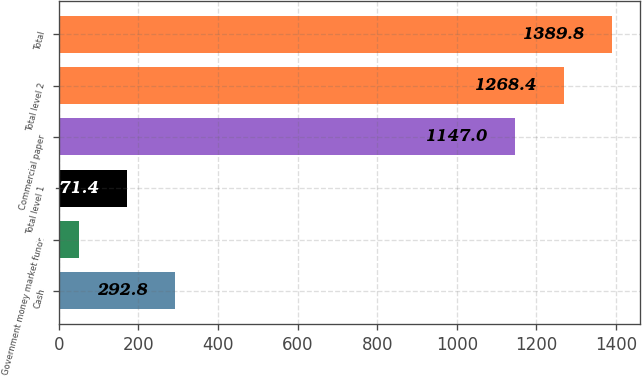Convert chart. <chart><loc_0><loc_0><loc_500><loc_500><bar_chart><fcel>Cash<fcel>Government money market funds<fcel>Total level 1<fcel>Commercial paper<fcel>Total level 2<fcel>Total<nl><fcel>292.8<fcel>50<fcel>171.4<fcel>1147<fcel>1268.4<fcel>1389.8<nl></chart> 